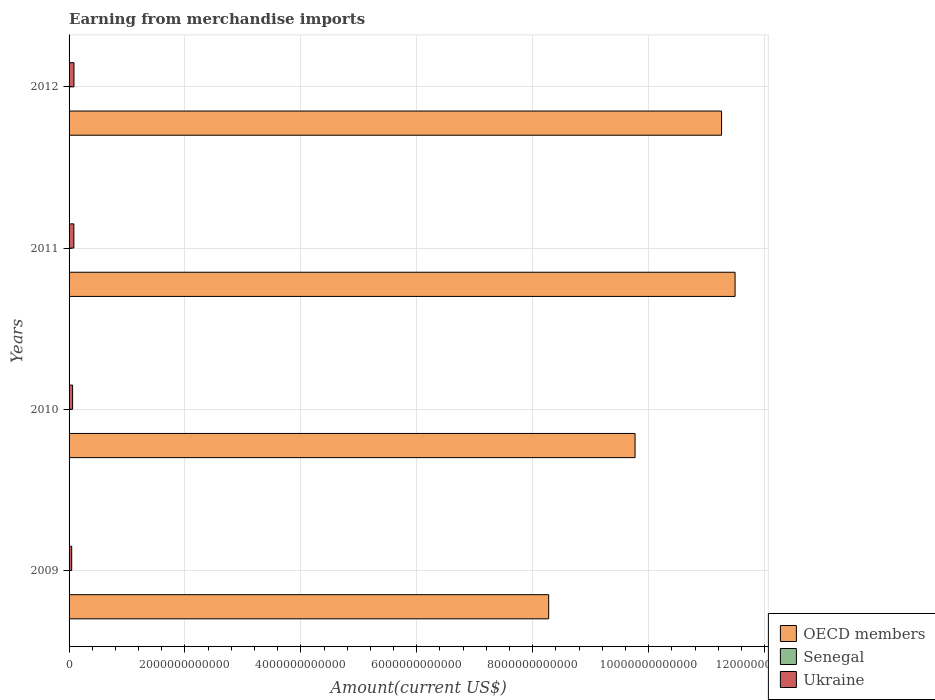Are the number of bars on each tick of the Y-axis equal?
Your answer should be very brief. Yes. How many bars are there on the 1st tick from the bottom?
Ensure brevity in your answer.  3. In how many cases, is the number of bars for a given year not equal to the number of legend labels?
Your answer should be compact. 0. What is the amount earned from merchandise imports in Senegal in 2012?
Provide a succinct answer. 6.43e+09. Across all years, what is the maximum amount earned from merchandise imports in OECD members?
Your answer should be compact. 1.15e+13. Across all years, what is the minimum amount earned from merchandise imports in OECD members?
Provide a short and direct response. 8.28e+12. In which year was the amount earned from merchandise imports in OECD members minimum?
Provide a succinct answer. 2009. What is the total amount earned from merchandise imports in Ukraine in the graph?
Provide a succinct answer. 2.74e+11. What is the difference between the amount earned from merchandise imports in Senegal in 2011 and that in 2012?
Provide a succinct answer. -5.25e+08. What is the difference between the amount earned from merchandise imports in OECD members in 2009 and the amount earned from merchandise imports in Ukraine in 2012?
Offer a very short reply. 8.19e+12. What is the average amount earned from merchandise imports in Senegal per year?
Provide a short and direct response. 5.46e+09. In the year 2009, what is the difference between the amount earned from merchandise imports in Ukraine and amount earned from merchandise imports in Senegal?
Offer a very short reply. 4.08e+1. What is the ratio of the amount earned from merchandise imports in Ukraine in 2009 to that in 2010?
Keep it short and to the point. 0.75. Is the difference between the amount earned from merchandise imports in Ukraine in 2009 and 2010 greater than the difference between the amount earned from merchandise imports in Senegal in 2009 and 2010?
Your answer should be compact. No. What is the difference between the highest and the second highest amount earned from merchandise imports in OECD members?
Provide a succinct answer. 2.33e+11. What is the difference between the highest and the lowest amount earned from merchandise imports in OECD members?
Your answer should be very brief. 3.22e+12. Is the sum of the amount earned from merchandise imports in OECD members in 2011 and 2012 greater than the maximum amount earned from merchandise imports in Senegal across all years?
Provide a succinct answer. Yes. What does the 3rd bar from the top in 2012 represents?
Offer a terse response. OECD members. What does the 2nd bar from the bottom in 2012 represents?
Provide a succinct answer. Senegal. Is it the case that in every year, the sum of the amount earned from merchandise imports in Senegal and amount earned from merchandise imports in Ukraine is greater than the amount earned from merchandise imports in OECD members?
Make the answer very short. No. How many bars are there?
Provide a succinct answer. 12. Are all the bars in the graph horizontal?
Give a very brief answer. Yes. How many years are there in the graph?
Your answer should be compact. 4. What is the difference between two consecutive major ticks on the X-axis?
Make the answer very short. 2.00e+12. Are the values on the major ticks of X-axis written in scientific E-notation?
Provide a succinct answer. No. Does the graph contain grids?
Give a very brief answer. Yes. Where does the legend appear in the graph?
Your response must be concise. Bottom right. How many legend labels are there?
Make the answer very short. 3. How are the legend labels stacked?
Your response must be concise. Vertical. What is the title of the graph?
Offer a very short reply. Earning from merchandise imports. What is the label or title of the X-axis?
Your answer should be compact. Amount(current US$). What is the label or title of the Y-axis?
Provide a succinct answer. Years. What is the Amount(current US$) in OECD members in 2009?
Provide a succinct answer. 8.28e+12. What is the Amount(current US$) in Senegal in 2009?
Provide a short and direct response. 4.71e+09. What is the Amount(current US$) of Ukraine in 2009?
Keep it short and to the point. 4.55e+1. What is the Amount(current US$) of OECD members in 2010?
Provide a short and direct response. 9.77e+12. What is the Amount(current US$) in Senegal in 2010?
Offer a very short reply. 4.78e+09. What is the Amount(current US$) of Ukraine in 2010?
Provide a short and direct response. 6.09e+1. What is the Amount(current US$) of OECD members in 2011?
Your answer should be compact. 1.15e+13. What is the Amount(current US$) of Senegal in 2011?
Ensure brevity in your answer.  5.91e+09. What is the Amount(current US$) in Ukraine in 2011?
Offer a terse response. 8.26e+1. What is the Amount(current US$) of OECD members in 2012?
Your response must be concise. 1.13e+13. What is the Amount(current US$) of Senegal in 2012?
Offer a terse response. 6.43e+09. What is the Amount(current US$) in Ukraine in 2012?
Provide a succinct answer. 8.46e+1. Across all years, what is the maximum Amount(current US$) of OECD members?
Offer a very short reply. 1.15e+13. Across all years, what is the maximum Amount(current US$) in Senegal?
Ensure brevity in your answer.  6.43e+09. Across all years, what is the maximum Amount(current US$) of Ukraine?
Offer a terse response. 8.46e+1. Across all years, what is the minimum Amount(current US$) of OECD members?
Offer a terse response. 8.28e+12. Across all years, what is the minimum Amount(current US$) of Senegal?
Provide a short and direct response. 4.71e+09. Across all years, what is the minimum Amount(current US$) of Ukraine?
Offer a very short reply. 4.55e+1. What is the total Amount(current US$) in OECD members in the graph?
Offer a very short reply. 4.08e+13. What is the total Amount(current US$) in Senegal in the graph?
Give a very brief answer. 2.18e+1. What is the total Amount(current US$) in Ukraine in the graph?
Your response must be concise. 2.74e+11. What is the difference between the Amount(current US$) of OECD members in 2009 and that in 2010?
Your answer should be compact. -1.49e+12. What is the difference between the Amount(current US$) of Senegal in 2009 and that in 2010?
Provide a short and direct response. -6.93e+07. What is the difference between the Amount(current US$) of Ukraine in 2009 and that in 2010?
Provide a short and direct response. -1.54e+1. What is the difference between the Amount(current US$) of OECD members in 2009 and that in 2011?
Your response must be concise. -3.22e+12. What is the difference between the Amount(current US$) of Senegal in 2009 and that in 2011?
Offer a very short reply. -1.20e+09. What is the difference between the Amount(current US$) in Ukraine in 2009 and that in 2011?
Your answer should be compact. -3.71e+1. What is the difference between the Amount(current US$) in OECD members in 2009 and that in 2012?
Keep it short and to the point. -2.98e+12. What is the difference between the Amount(current US$) in Senegal in 2009 and that in 2012?
Provide a short and direct response. -1.72e+09. What is the difference between the Amount(current US$) in Ukraine in 2009 and that in 2012?
Make the answer very short. -3.92e+1. What is the difference between the Amount(current US$) of OECD members in 2010 and that in 2011?
Your response must be concise. -1.73e+12. What is the difference between the Amount(current US$) of Senegal in 2010 and that in 2011?
Keep it short and to the point. -1.13e+09. What is the difference between the Amount(current US$) in Ukraine in 2010 and that in 2011?
Provide a short and direct response. -2.17e+1. What is the difference between the Amount(current US$) of OECD members in 2010 and that in 2012?
Your response must be concise. -1.49e+12. What is the difference between the Amount(current US$) in Senegal in 2010 and that in 2012?
Your answer should be compact. -1.65e+09. What is the difference between the Amount(current US$) of Ukraine in 2010 and that in 2012?
Give a very brief answer. -2.37e+1. What is the difference between the Amount(current US$) in OECD members in 2011 and that in 2012?
Give a very brief answer. 2.33e+11. What is the difference between the Amount(current US$) in Senegal in 2011 and that in 2012?
Make the answer very short. -5.25e+08. What is the difference between the Amount(current US$) in Ukraine in 2011 and that in 2012?
Offer a very short reply. -2.04e+09. What is the difference between the Amount(current US$) in OECD members in 2009 and the Amount(current US$) in Senegal in 2010?
Provide a short and direct response. 8.27e+12. What is the difference between the Amount(current US$) in OECD members in 2009 and the Amount(current US$) in Ukraine in 2010?
Your response must be concise. 8.21e+12. What is the difference between the Amount(current US$) of Senegal in 2009 and the Amount(current US$) of Ukraine in 2010?
Keep it short and to the point. -5.62e+1. What is the difference between the Amount(current US$) of OECD members in 2009 and the Amount(current US$) of Senegal in 2011?
Keep it short and to the point. 8.27e+12. What is the difference between the Amount(current US$) of OECD members in 2009 and the Amount(current US$) of Ukraine in 2011?
Ensure brevity in your answer.  8.19e+12. What is the difference between the Amount(current US$) in Senegal in 2009 and the Amount(current US$) in Ukraine in 2011?
Make the answer very short. -7.79e+1. What is the difference between the Amount(current US$) of OECD members in 2009 and the Amount(current US$) of Senegal in 2012?
Your response must be concise. 8.27e+12. What is the difference between the Amount(current US$) of OECD members in 2009 and the Amount(current US$) of Ukraine in 2012?
Keep it short and to the point. 8.19e+12. What is the difference between the Amount(current US$) in Senegal in 2009 and the Amount(current US$) in Ukraine in 2012?
Keep it short and to the point. -7.99e+1. What is the difference between the Amount(current US$) in OECD members in 2010 and the Amount(current US$) in Senegal in 2011?
Ensure brevity in your answer.  9.76e+12. What is the difference between the Amount(current US$) in OECD members in 2010 and the Amount(current US$) in Ukraine in 2011?
Your answer should be very brief. 9.68e+12. What is the difference between the Amount(current US$) of Senegal in 2010 and the Amount(current US$) of Ukraine in 2011?
Provide a succinct answer. -7.78e+1. What is the difference between the Amount(current US$) of OECD members in 2010 and the Amount(current US$) of Senegal in 2012?
Offer a terse response. 9.76e+12. What is the difference between the Amount(current US$) in OECD members in 2010 and the Amount(current US$) in Ukraine in 2012?
Offer a very short reply. 9.68e+12. What is the difference between the Amount(current US$) in Senegal in 2010 and the Amount(current US$) in Ukraine in 2012?
Offer a very short reply. -7.99e+1. What is the difference between the Amount(current US$) of OECD members in 2011 and the Amount(current US$) of Senegal in 2012?
Keep it short and to the point. 1.15e+13. What is the difference between the Amount(current US$) in OECD members in 2011 and the Amount(current US$) in Ukraine in 2012?
Keep it short and to the point. 1.14e+13. What is the difference between the Amount(current US$) in Senegal in 2011 and the Amount(current US$) in Ukraine in 2012?
Give a very brief answer. -7.87e+1. What is the average Amount(current US$) in OECD members per year?
Provide a short and direct response. 1.02e+13. What is the average Amount(current US$) of Senegal per year?
Your answer should be compact. 5.46e+09. What is the average Amount(current US$) in Ukraine per year?
Your answer should be very brief. 6.84e+1. In the year 2009, what is the difference between the Amount(current US$) of OECD members and Amount(current US$) of Senegal?
Offer a very short reply. 8.27e+12. In the year 2009, what is the difference between the Amount(current US$) in OECD members and Amount(current US$) in Ukraine?
Your response must be concise. 8.23e+12. In the year 2009, what is the difference between the Amount(current US$) in Senegal and Amount(current US$) in Ukraine?
Offer a very short reply. -4.08e+1. In the year 2010, what is the difference between the Amount(current US$) of OECD members and Amount(current US$) of Senegal?
Your response must be concise. 9.76e+12. In the year 2010, what is the difference between the Amount(current US$) of OECD members and Amount(current US$) of Ukraine?
Offer a very short reply. 9.70e+12. In the year 2010, what is the difference between the Amount(current US$) of Senegal and Amount(current US$) of Ukraine?
Your answer should be compact. -5.61e+1. In the year 2011, what is the difference between the Amount(current US$) of OECD members and Amount(current US$) of Senegal?
Provide a succinct answer. 1.15e+13. In the year 2011, what is the difference between the Amount(current US$) of OECD members and Amount(current US$) of Ukraine?
Provide a succinct answer. 1.14e+13. In the year 2011, what is the difference between the Amount(current US$) of Senegal and Amount(current US$) of Ukraine?
Provide a succinct answer. -7.67e+1. In the year 2012, what is the difference between the Amount(current US$) of OECD members and Amount(current US$) of Senegal?
Your answer should be compact. 1.13e+13. In the year 2012, what is the difference between the Amount(current US$) in OECD members and Amount(current US$) in Ukraine?
Your response must be concise. 1.12e+13. In the year 2012, what is the difference between the Amount(current US$) in Senegal and Amount(current US$) in Ukraine?
Your response must be concise. -7.82e+1. What is the ratio of the Amount(current US$) in OECD members in 2009 to that in 2010?
Your answer should be very brief. 0.85. What is the ratio of the Amount(current US$) of Senegal in 2009 to that in 2010?
Provide a short and direct response. 0.99. What is the ratio of the Amount(current US$) of Ukraine in 2009 to that in 2010?
Offer a terse response. 0.75. What is the ratio of the Amount(current US$) in OECD members in 2009 to that in 2011?
Provide a succinct answer. 0.72. What is the ratio of the Amount(current US$) of Senegal in 2009 to that in 2011?
Give a very brief answer. 0.8. What is the ratio of the Amount(current US$) in Ukraine in 2009 to that in 2011?
Offer a terse response. 0.55. What is the ratio of the Amount(current US$) of OECD members in 2009 to that in 2012?
Ensure brevity in your answer.  0.74. What is the ratio of the Amount(current US$) in Senegal in 2009 to that in 2012?
Give a very brief answer. 0.73. What is the ratio of the Amount(current US$) of Ukraine in 2009 to that in 2012?
Provide a short and direct response. 0.54. What is the ratio of the Amount(current US$) in OECD members in 2010 to that in 2011?
Offer a terse response. 0.85. What is the ratio of the Amount(current US$) of Senegal in 2010 to that in 2011?
Your answer should be compact. 0.81. What is the ratio of the Amount(current US$) in Ukraine in 2010 to that in 2011?
Keep it short and to the point. 0.74. What is the ratio of the Amount(current US$) in OECD members in 2010 to that in 2012?
Your answer should be compact. 0.87. What is the ratio of the Amount(current US$) in Senegal in 2010 to that in 2012?
Ensure brevity in your answer.  0.74. What is the ratio of the Amount(current US$) in Ukraine in 2010 to that in 2012?
Your answer should be very brief. 0.72. What is the ratio of the Amount(current US$) of OECD members in 2011 to that in 2012?
Provide a short and direct response. 1.02. What is the ratio of the Amount(current US$) in Senegal in 2011 to that in 2012?
Make the answer very short. 0.92. What is the ratio of the Amount(current US$) of Ukraine in 2011 to that in 2012?
Offer a very short reply. 0.98. What is the difference between the highest and the second highest Amount(current US$) of OECD members?
Offer a very short reply. 2.33e+11. What is the difference between the highest and the second highest Amount(current US$) of Senegal?
Your response must be concise. 5.25e+08. What is the difference between the highest and the second highest Amount(current US$) in Ukraine?
Your response must be concise. 2.04e+09. What is the difference between the highest and the lowest Amount(current US$) in OECD members?
Give a very brief answer. 3.22e+12. What is the difference between the highest and the lowest Amount(current US$) of Senegal?
Provide a short and direct response. 1.72e+09. What is the difference between the highest and the lowest Amount(current US$) in Ukraine?
Provide a succinct answer. 3.92e+1. 